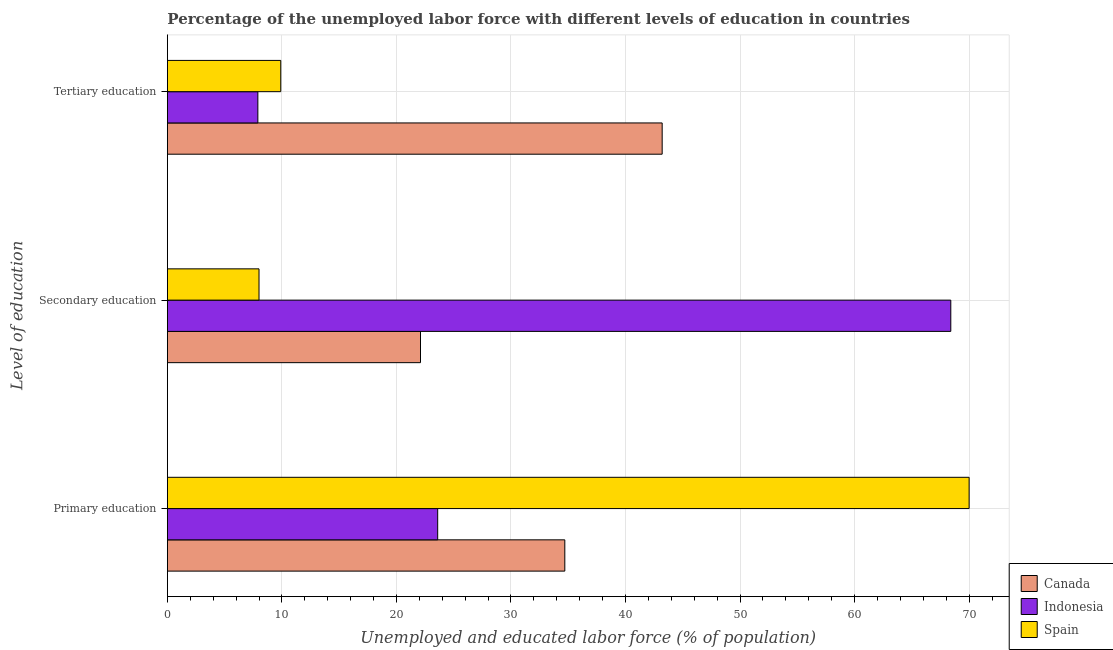Are the number of bars per tick equal to the number of legend labels?
Provide a succinct answer. Yes. Are the number of bars on each tick of the Y-axis equal?
Give a very brief answer. Yes. How many bars are there on the 2nd tick from the top?
Keep it short and to the point. 3. How many bars are there on the 2nd tick from the bottom?
Give a very brief answer. 3. What is the label of the 1st group of bars from the top?
Give a very brief answer. Tertiary education. What is the percentage of labor force who received secondary education in Canada?
Keep it short and to the point. 22.1. Across all countries, what is the maximum percentage of labor force who received tertiary education?
Give a very brief answer. 43.2. Across all countries, what is the minimum percentage of labor force who received secondary education?
Offer a terse response. 8. In which country was the percentage of labor force who received primary education maximum?
Ensure brevity in your answer.  Spain. What is the total percentage of labor force who received secondary education in the graph?
Make the answer very short. 98.5. What is the difference between the percentage of labor force who received primary education in Indonesia and that in Canada?
Provide a short and direct response. -11.1. What is the difference between the percentage of labor force who received primary education in Indonesia and the percentage of labor force who received tertiary education in Spain?
Your answer should be very brief. 13.7. What is the average percentage of labor force who received secondary education per country?
Offer a terse response. 32.83. What is the difference between the percentage of labor force who received tertiary education and percentage of labor force who received primary education in Indonesia?
Your answer should be very brief. -15.7. What is the ratio of the percentage of labor force who received secondary education in Spain to that in Indonesia?
Your answer should be compact. 0.12. Is the percentage of labor force who received secondary education in Canada less than that in Spain?
Keep it short and to the point. No. What is the difference between the highest and the second highest percentage of labor force who received primary education?
Provide a succinct answer. 35.3. What is the difference between the highest and the lowest percentage of labor force who received tertiary education?
Ensure brevity in your answer.  35.3. In how many countries, is the percentage of labor force who received tertiary education greater than the average percentage of labor force who received tertiary education taken over all countries?
Provide a short and direct response. 1. What does the 2nd bar from the bottom in Secondary education represents?
Provide a succinct answer. Indonesia. Is it the case that in every country, the sum of the percentage of labor force who received primary education and percentage of labor force who received secondary education is greater than the percentage of labor force who received tertiary education?
Provide a succinct answer. Yes. What is the difference between two consecutive major ticks on the X-axis?
Your answer should be very brief. 10. Does the graph contain any zero values?
Your answer should be compact. No. Does the graph contain grids?
Your answer should be very brief. Yes. Where does the legend appear in the graph?
Offer a terse response. Bottom right. What is the title of the graph?
Provide a short and direct response. Percentage of the unemployed labor force with different levels of education in countries. What is the label or title of the X-axis?
Give a very brief answer. Unemployed and educated labor force (% of population). What is the label or title of the Y-axis?
Your response must be concise. Level of education. What is the Unemployed and educated labor force (% of population) of Canada in Primary education?
Keep it short and to the point. 34.7. What is the Unemployed and educated labor force (% of population) in Indonesia in Primary education?
Offer a terse response. 23.6. What is the Unemployed and educated labor force (% of population) in Canada in Secondary education?
Ensure brevity in your answer.  22.1. What is the Unemployed and educated labor force (% of population) of Indonesia in Secondary education?
Provide a succinct answer. 68.4. What is the Unemployed and educated labor force (% of population) in Spain in Secondary education?
Your answer should be very brief. 8. What is the Unemployed and educated labor force (% of population) in Canada in Tertiary education?
Your answer should be compact. 43.2. What is the Unemployed and educated labor force (% of population) of Indonesia in Tertiary education?
Your response must be concise. 7.9. What is the Unemployed and educated labor force (% of population) in Spain in Tertiary education?
Offer a terse response. 9.9. Across all Level of education, what is the maximum Unemployed and educated labor force (% of population) in Canada?
Your answer should be very brief. 43.2. Across all Level of education, what is the maximum Unemployed and educated labor force (% of population) in Indonesia?
Keep it short and to the point. 68.4. Across all Level of education, what is the maximum Unemployed and educated labor force (% of population) of Spain?
Provide a short and direct response. 70. Across all Level of education, what is the minimum Unemployed and educated labor force (% of population) in Canada?
Your response must be concise. 22.1. Across all Level of education, what is the minimum Unemployed and educated labor force (% of population) in Indonesia?
Offer a very short reply. 7.9. What is the total Unemployed and educated labor force (% of population) of Indonesia in the graph?
Keep it short and to the point. 99.9. What is the total Unemployed and educated labor force (% of population) of Spain in the graph?
Offer a terse response. 87.9. What is the difference between the Unemployed and educated labor force (% of population) of Canada in Primary education and that in Secondary education?
Offer a very short reply. 12.6. What is the difference between the Unemployed and educated labor force (% of population) of Indonesia in Primary education and that in Secondary education?
Give a very brief answer. -44.8. What is the difference between the Unemployed and educated labor force (% of population) of Indonesia in Primary education and that in Tertiary education?
Offer a terse response. 15.7. What is the difference between the Unemployed and educated labor force (% of population) in Spain in Primary education and that in Tertiary education?
Your response must be concise. 60.1. What is the difference between the Unemployed and educated labor force (% of population) of Canada in Secondary education and that in Tertiary education?
Ensure brevity in your answer.  -21.1. What is the difference between the Unemployed and educated labor force (% of population) in Indonesia in Secondary education and that in Tertiary education?
Offer a very short reply. 60.5. What is the difference between the Unemployed and educated labor force (% of population) of Spain in Secondary education and that in Tertiary education?
Provide a short and direct response. -1.9. What is the difference between the Unemployed and educated labor force (% of population) of Canada in Primary education and the Unemployed and educated labor force (% of population) of Indonesia in Secondary education?
Provide a short and direct response. -33.7. What is the difference between the Unemployed and educated labor force (% of population) of Canada in Primary education and the Unemployed and educated labor force (% of population) of Spain in Secondary education?
Provide a short and direct response. 26.7. What is the difference between the Unemployed and educated labor force (% of population) in Indonesia in Primary education and the Unemployed and educated labor force (% of population) in Spain in Secondary education?
Your response must be concise. 15.6. What is the difference between the Unemployed and educated labor force (% of population) in Canada in Primary education and the Unemployed and educated labor force (% of population) in Indonesia in Tertiary education?
Ensure brevity in your answer.  26.8. What is the difference between the Unemployed and educated labor force (% of population) in Canada in Primary education and the Unemployed and educated labor force (% of population) in Spain in Tertiary education?
Make the answer very short. 24.8. What is the difference between the Unemployed and educated labor force (% of population) in Indonesia in Primary education and the Unemployed and educated labor force (% of population) in Spain in Tertiary education?
Provide a succinct answer. 13.7. What is the difference between the Unemployed and educated labor force (% of population) in Canada in Secondary education and the Unemployed and educated labor force (% of population) in Indonesia in Tertiary education?
Offer a terse response. 14.2. What is the difference between the Unemployed and educated labor force (% of population) of Indonesia in Secondary education and the Unemployed and educated labor force (% of population) of Spain in Tertiary education?
Offer a terse response. 58.5. What is the average Unemployed and educated labor force (% of population) in Canada per Level of education?
Your answer should be very brief. 33.33. What is the average Unemployed and educated labor force (% of population) of Indonesia per Level of education?
Provide a short and direct response. 33.3. What is the average Unemployed and educated labor force (% of population) in Spain per Level of education?
Ensure brevity in your answer.  29.3. What is the difference between the Unemployed and educated labor force (% of population) of Canada and Unemployed and educated labor force (% of population) of Spain in Primary education?
Keep it short and to the point. -35.3. What is the difference between the Unemployed and educated labor force (% of population) of Indonesia and Unemployed and educated labor force (% of population) of Spain in Primary education?
Keep it short and to the point. -46.4. What is the difference between the Unemployed and educated labor force (% of population) of Canada and Unemployed and educated labor force (% of population) of Indonesia in Secondary education?
Offer a very short reply. -46.3. What is the difference between the Unemployed and educated labor force (% of population) in Indonesia and Unemployed and educated labor force (% of population) in Spain in Secondary education?
Offer a very short reply. 60.4. What is the difference between the Unemployed and educated labor force (% of population) in Canada and Unemployed and educated labor force (% of population) in Indonesia in Tertiary education?
Provide a succinct answer. 35.3. What is the difference between the Unemployed and educated labor force (% of population) of Canada and Unemployed and educated labor force (% of population) of Spain in Tertiary education?
Ensure brevity in your answer.  33.3. What is the difference between the Unemployed and educated labor force (% of population) in Indonesia and Unemployed and educated labor force (% of population) in Spain in Tertiary education?
Give a very brief answer. -2. What is the ratio of the Unemployed and educated labor force (% of population) in Canada in Primary education to that in Secondary education?
Give a very brief answer. 1.57. What is the ratio of the Unemployed and educated labor force (% of population) in Indonesia in Primary education to that in Secondary education?
Offer a very short reply. 0.34. What is the ratio of the Unemployed and educated labor force (% of population) in Spain in Primary education to that in Secondary education?
Make the answer very short. 8.75. What is the ratio of the Unemployed and educated labor force (% of population) in Canada in Primary education to that in Tertiary education?
Offer a very short reply. 0.8. What is the ratio of the Unemployed and educated labor force (% of population) of Indonesia in Primary education to that in Tertiary education?
Make the answer very short. 2.99. What is the ratio of the Unemployed and educated labor force (% of population) of Spain in Primary education to that in Tertiary education?
Offer a very short reply. 7.07. What is the ratio of the Unemployed and educated labor force (% of population) of Canada in Secondary education to that in Tertiary education?
Offer a very short reply. 0.51. What is the ratio of the Unemployed and educated labor force (% of population) in Indonesia in Secondary education to that in Tertiary education?
Provide a succinct answer. 8.66. What is the ratio of the Unemployed and educated labor force (% of population) of Spain in Secondary education to that in Tertiary education?
Offer a very short reply. 0.81. What is the difference between the highest and the second highest Unemployed and educated labor force (% of population) of Canada?
Ensure brevity in your answer.  8.5. What is the difference between the highest and the second highest Unemployed and educated labor force (% of population) in Indonesia?
Offer a terse response. 44.8. What is the difference between the highest and the second highest Unemployed and educated labor force (% of population) of Spain?
Ensure brevity in your answer.  60.1. What is the difference between the highest and the lowest Unemployed and educated labor force (% of population) of Canada?
Your answer should be very brief. 21.1. What is the difference between the highest and the lowest Unemployed and educated labor force (% of population) of Indonesia?
Make the answer very short. 60.5. What is the difference between the highest and the lowest Unemployed and educated labor force (% of population) in Spain?
Your answer should be compact. 62. 